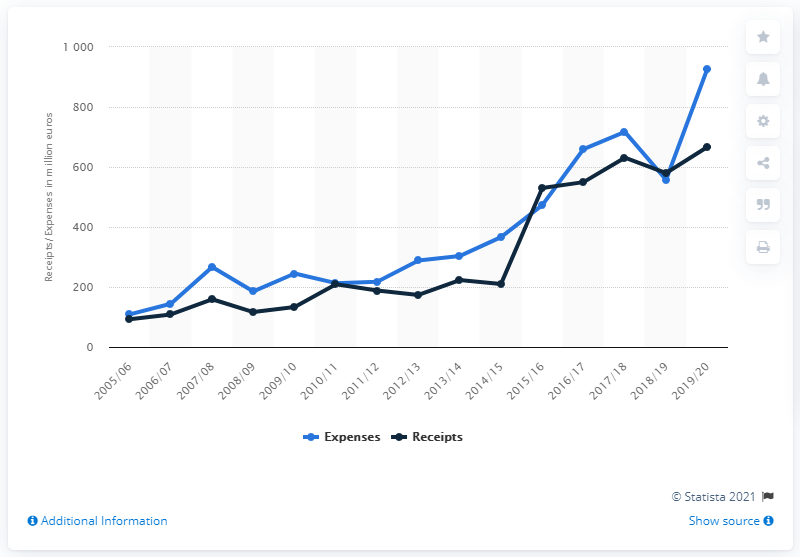Draw attention to some important aspects in this diagram. The value of player transfer fees in the 2017/18 season was 716.99. 